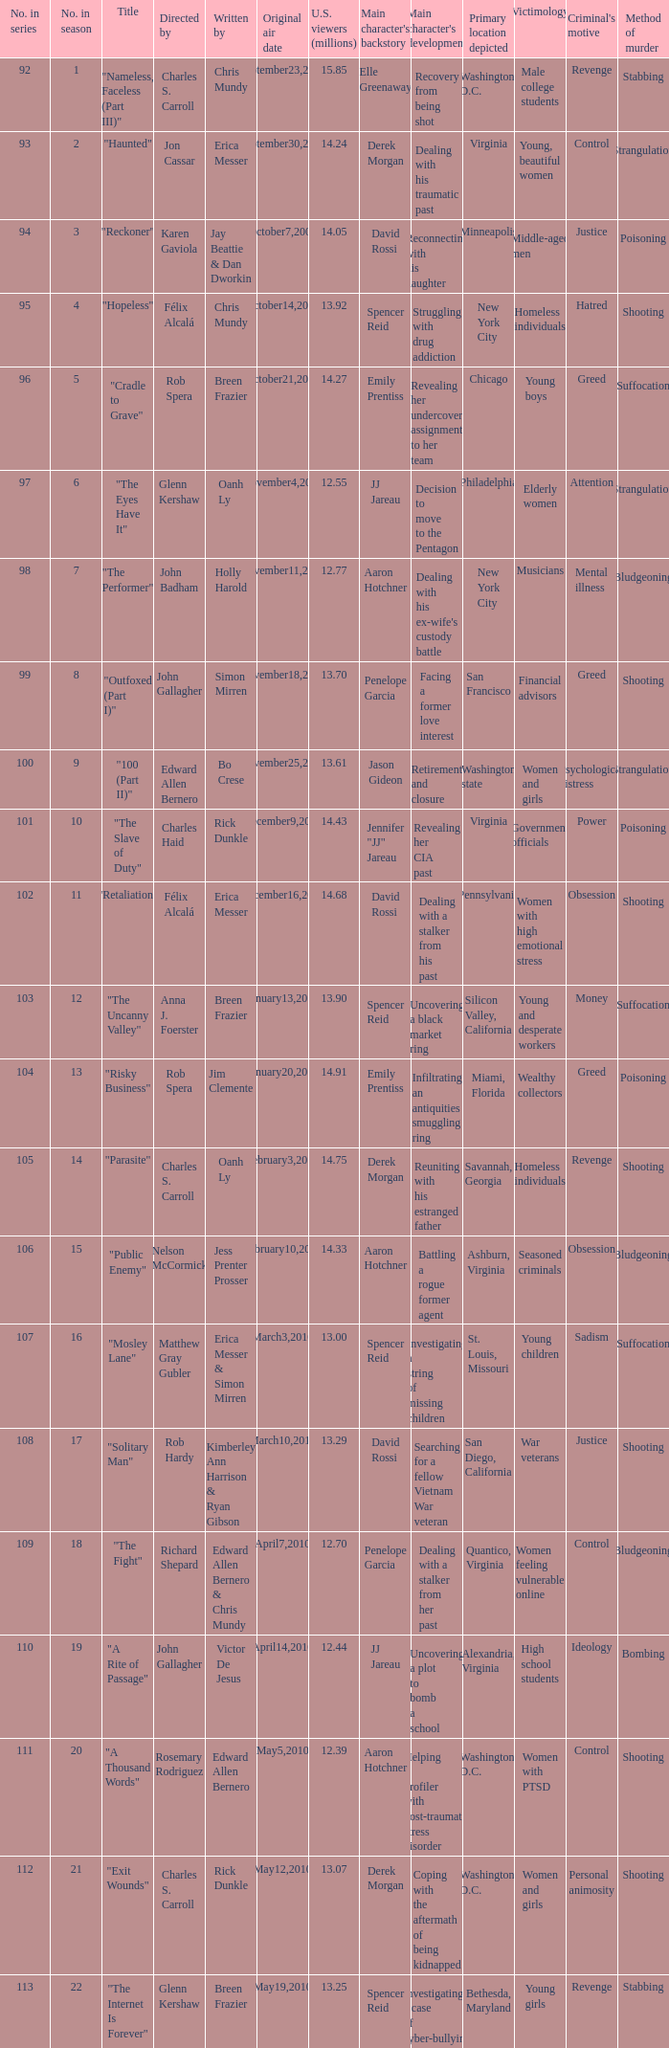What season included the "haunted" episode? 2.0. 